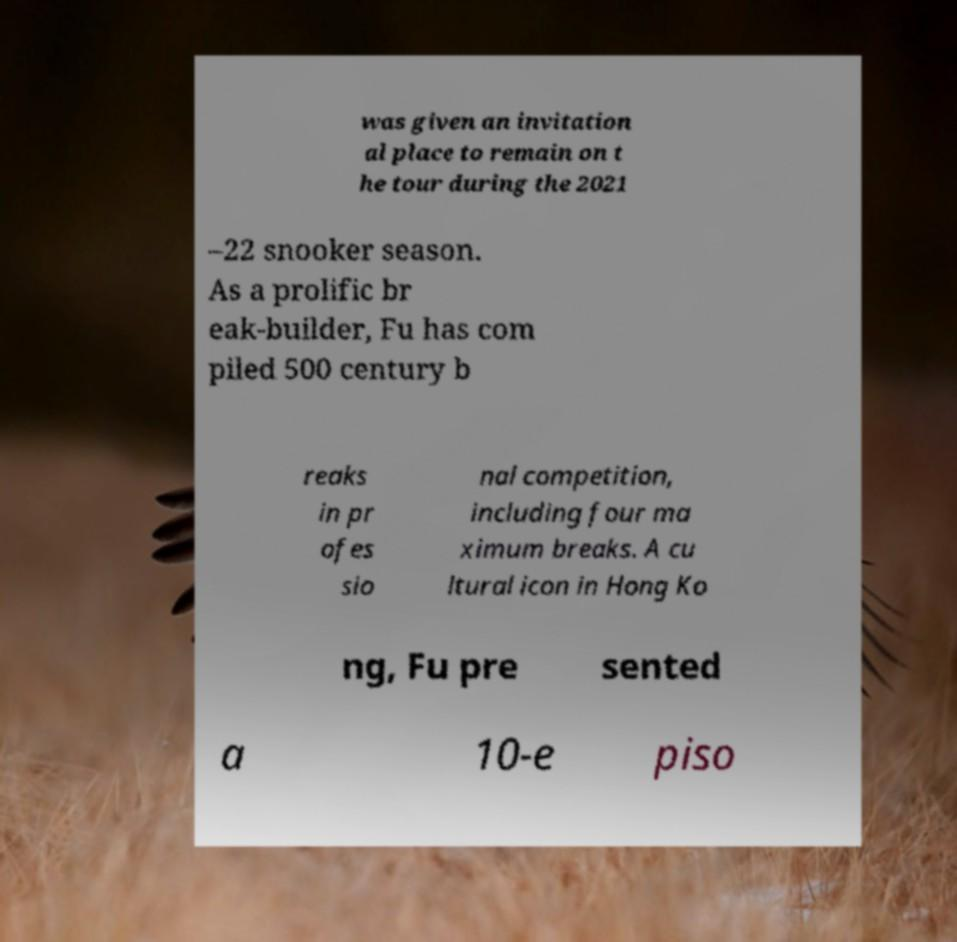I need the written content from this picture converted into text. Can you do that? was given an invitation al place to remain on t he tour during the 2021 –22 snooker season. As a prolific br eak-builder, Fu has com piled 500 century b reaks in pr ofes sio nal competition, including four ma ximum breaks. A cu ltural icon in Hong Ko ng, Fu pre sented a 10-e piso 